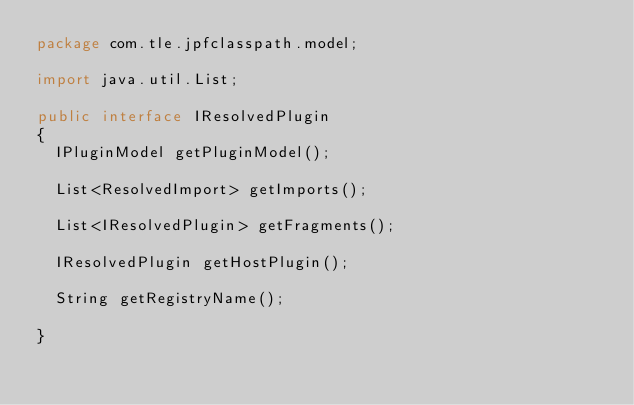<code> <loc_0><loc_0><loc_500><loc_500><_Java_>package com.tle.jpfclasspath.model;

import java.util.List;

public interface IResolvedPlugin
{
	IPluginModel getPluginModel();

	List<ResolvedImport> getImports();

	List<IResolvedPlugin> getFragments();

	IResolvedPlugin getHostPlugin();

	String getRegistryName();

}
</code> 